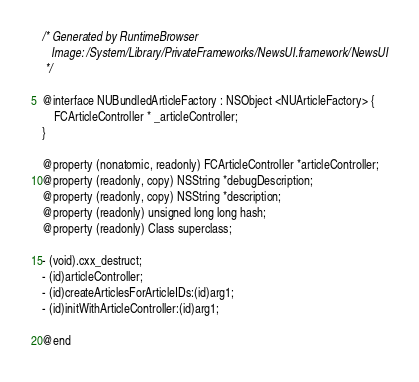Convert code to text. <code><loc_0><loc_0><loc_500><loc_500><_C_>/* Generated by RuntimeBrowser
   Image: /System/Library/PrivateFrameworks/NewsUI.framework/NewsUI
 */

@interface NUBundledArticleFactory : NSObject <NUArticleFactory> {
    FCArticleController * _articleController;
}

@property (nonatomic, readonly) FCArticleController *articleController;
@property (readonly, copy) NSString *debugDescription;
@property (readonly, copy) NSString *description;
@property (readonly) unsigned long long hash;
@property (readonly) Class superclass;

- (void).cxx_destruct;
- (id)articleController;
- (id)createArticlesForArticleIDs:(id)arg1;
- (id)initWithArticleController:(id)arg1;

@end
</code> 